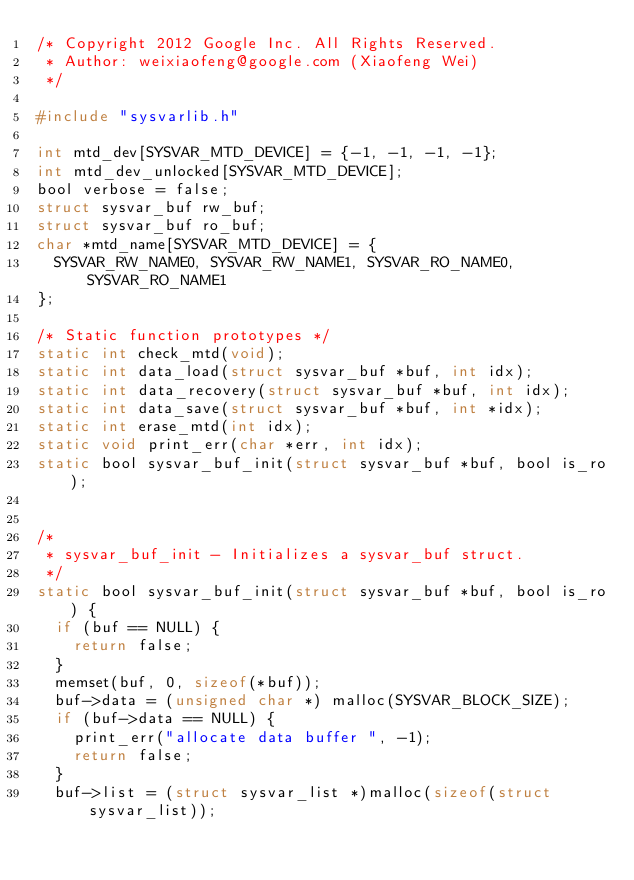Convert code to text. <code><loc_0><loc_0><loc_500><loc_500><_C_>/* Copyright 2012 Google Inc. All Rights Reserved.
 * Author: weixiaofeng@google.com (Xiaofeng Wei)
 */

#include "sysvarlib.h"

int mtd_dev[SYSVAR_MTD_DEVICE] = {-1, -1, -1, -1};
int mtd_dev_unlocked[SYSVAR_MTD_DEVICE];
bool verbose = false;
struct sysvar_buf rw_buf;
struct sysvar_buf ro_buf;
char *mtd_name[SYSVAR_MTD_DEVICE] = {
  SYSVAR_RW_NAME0, SYSVAR_RW_NAME1, SYSVAR_RO_NAME0, SYSVAR_RO_NAME1
};

/* Static function prototypes */
static int check_mtd(void);
static int data_load(struct sysvar_buf *buf, int idx);
static int data_recovery(struct sysvar_buf *buf, int idx);
static int data_save(struct sysvar_buf *buf, int *idx);
static int erase_mtd(int idx);
static void print_err(char *err, int idx);
static bool sysvar_buf_init(struct sysvar_buf *buf, bool is_ro);


/*
 * sysvar_buf_init - Initializes a sysvar_buf struct.
 */
static bool sysvar_buf_init(struct sysvar_buf *buf, bool is_ro) {
  if (buf == NULL) {
    return false;
  }
  memset(buf, 0, sizeof(*buf));
  buf->data = (unsigned char *) malloc(SYSVAR_BLOCK_SIZE);
  if (buf->data == NULL) {
    print_err("allocate data buffer ", -1);
    return false;
  }
  buf->list = (struct sysvar_list *)malloc(sizeof(struct sysvar_list));</code> 